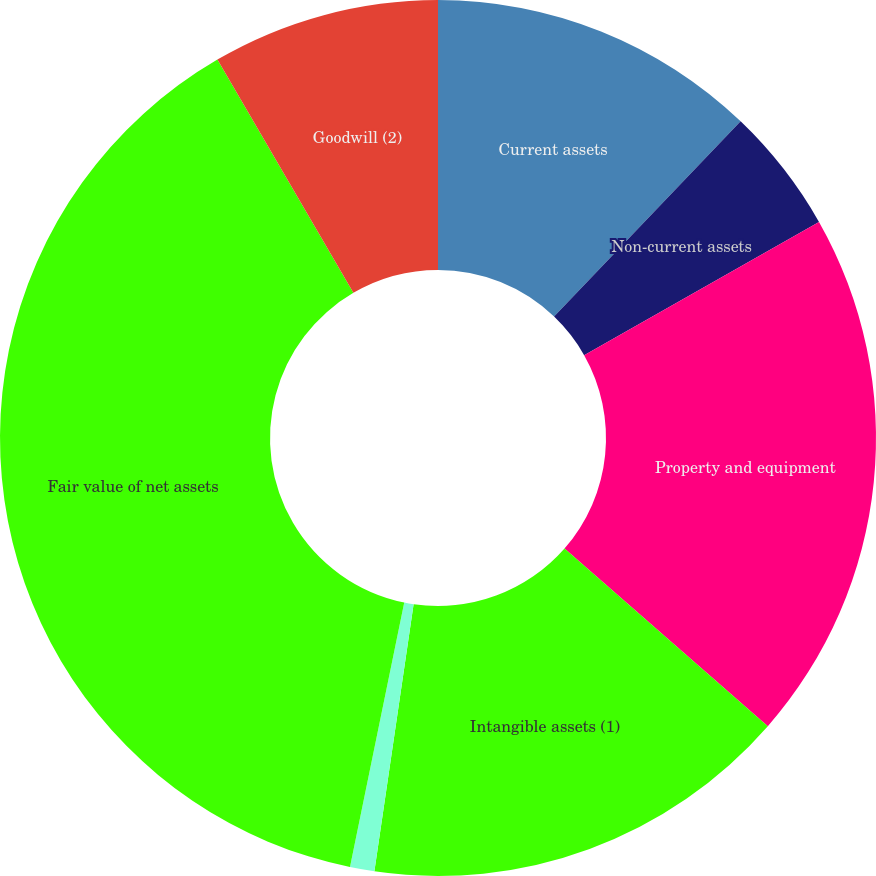Convert chart to OTSL. <chart><loc_0><loc_0><loc_500><loc_500><pie_chart><fcel>Current assets<fcel>Non-current assets<fcel>Property and equipment<fcel>Intangible assets (1)<fcel>Other non-current liabilities<fcel>Fair value of net assets<fcel>Goodwill (2)<nl><fcel>12.14%<fcel>4.65%<fcel>19.64%<fcel>15.89%<fcel>0.9%<fcel>38.38%<fcel>8.4%<nl></chart> 